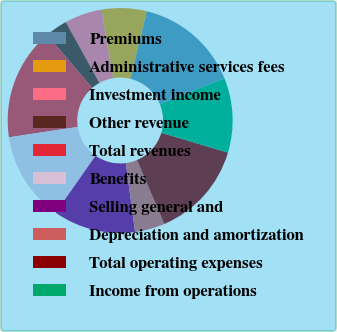<chart> <loc_0><loc_0><loc_500><loc_500><pie_chart><fcel>Premiums<fcel>Administrative services fees<fcel>Investment income<fcel>Other revenue<fcel>Total revenues<fcel>Benefits<fcel>Selling general and<fcel>Depreciation and amortization<fcel>Total operating expenses<fcel>Income from operations<nl><fcel>15.05%<fcel>6.45%<fcel>5.38%<fcel>3.23%<fcel>16.13%<fcel>12.9%<fcel>11.83%<fcel>4.3%<fcel>13.98%<fcel>10.75%<nl></chart> 